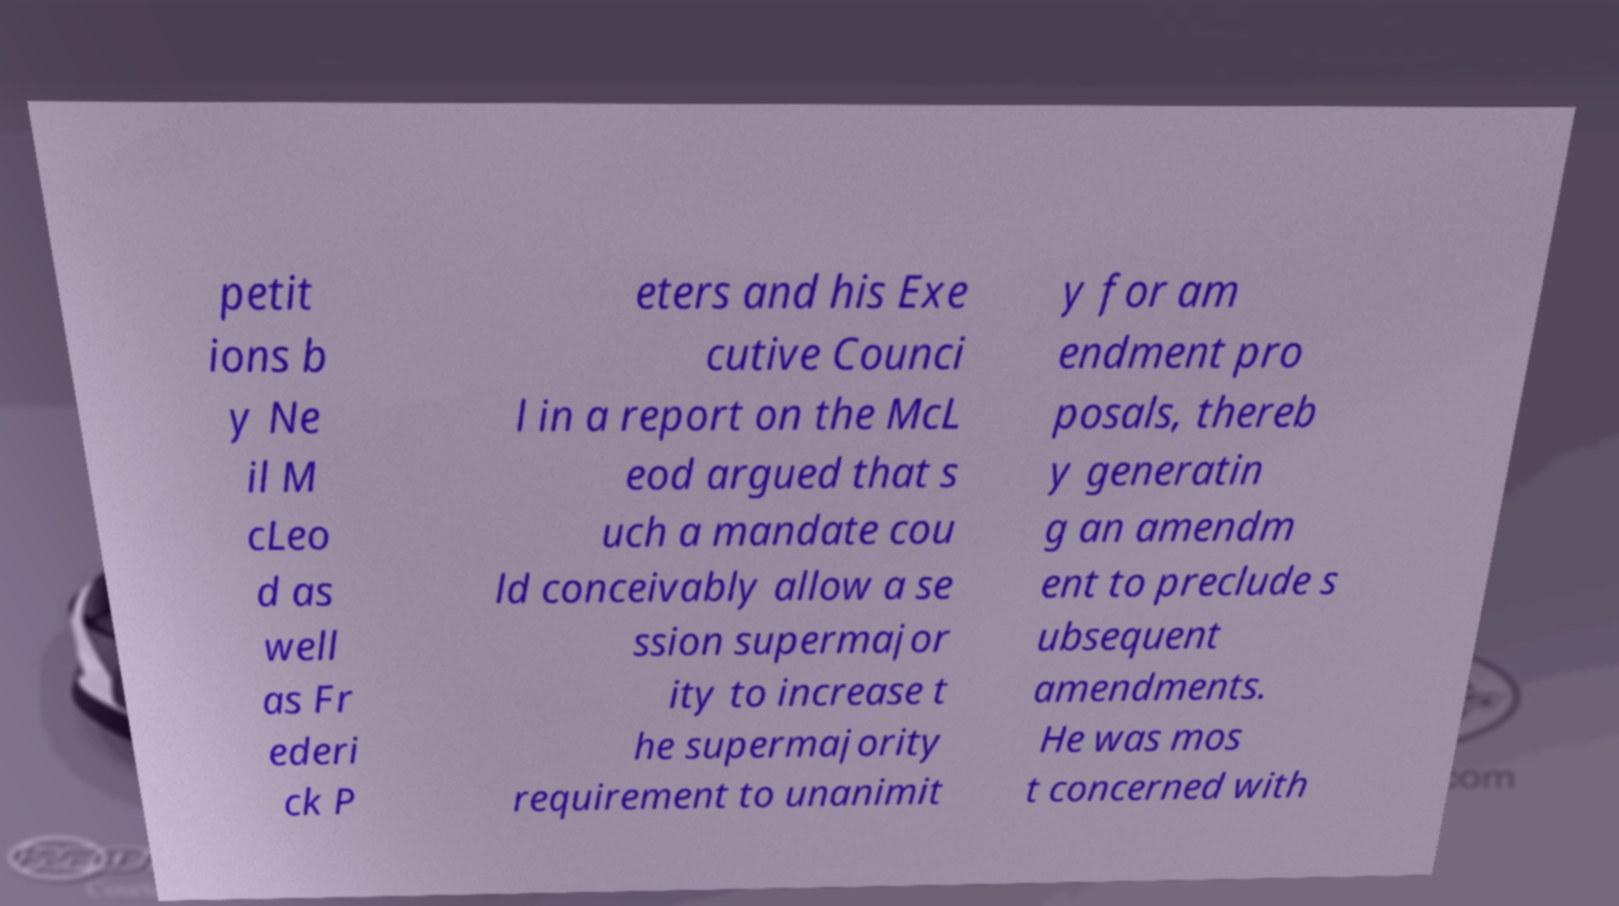Can you read and provide the text displayed in the image?This photo seems to have some interesting text. Can you extract and type it out for me? petit ions b y Ne il M cLeo d as well as Fr ederi ck P eters and his Exe cutive Counci l in a report on the McL eod argued that s uch a mandate cou ld conceivably allow a se ssion supermajor ity to increase t he supermajority requirement to unanimit y for am endment pro posals, thereb y generatin g an amendm ent to preclude s ubsequent amendments. He was mos t concerned with 